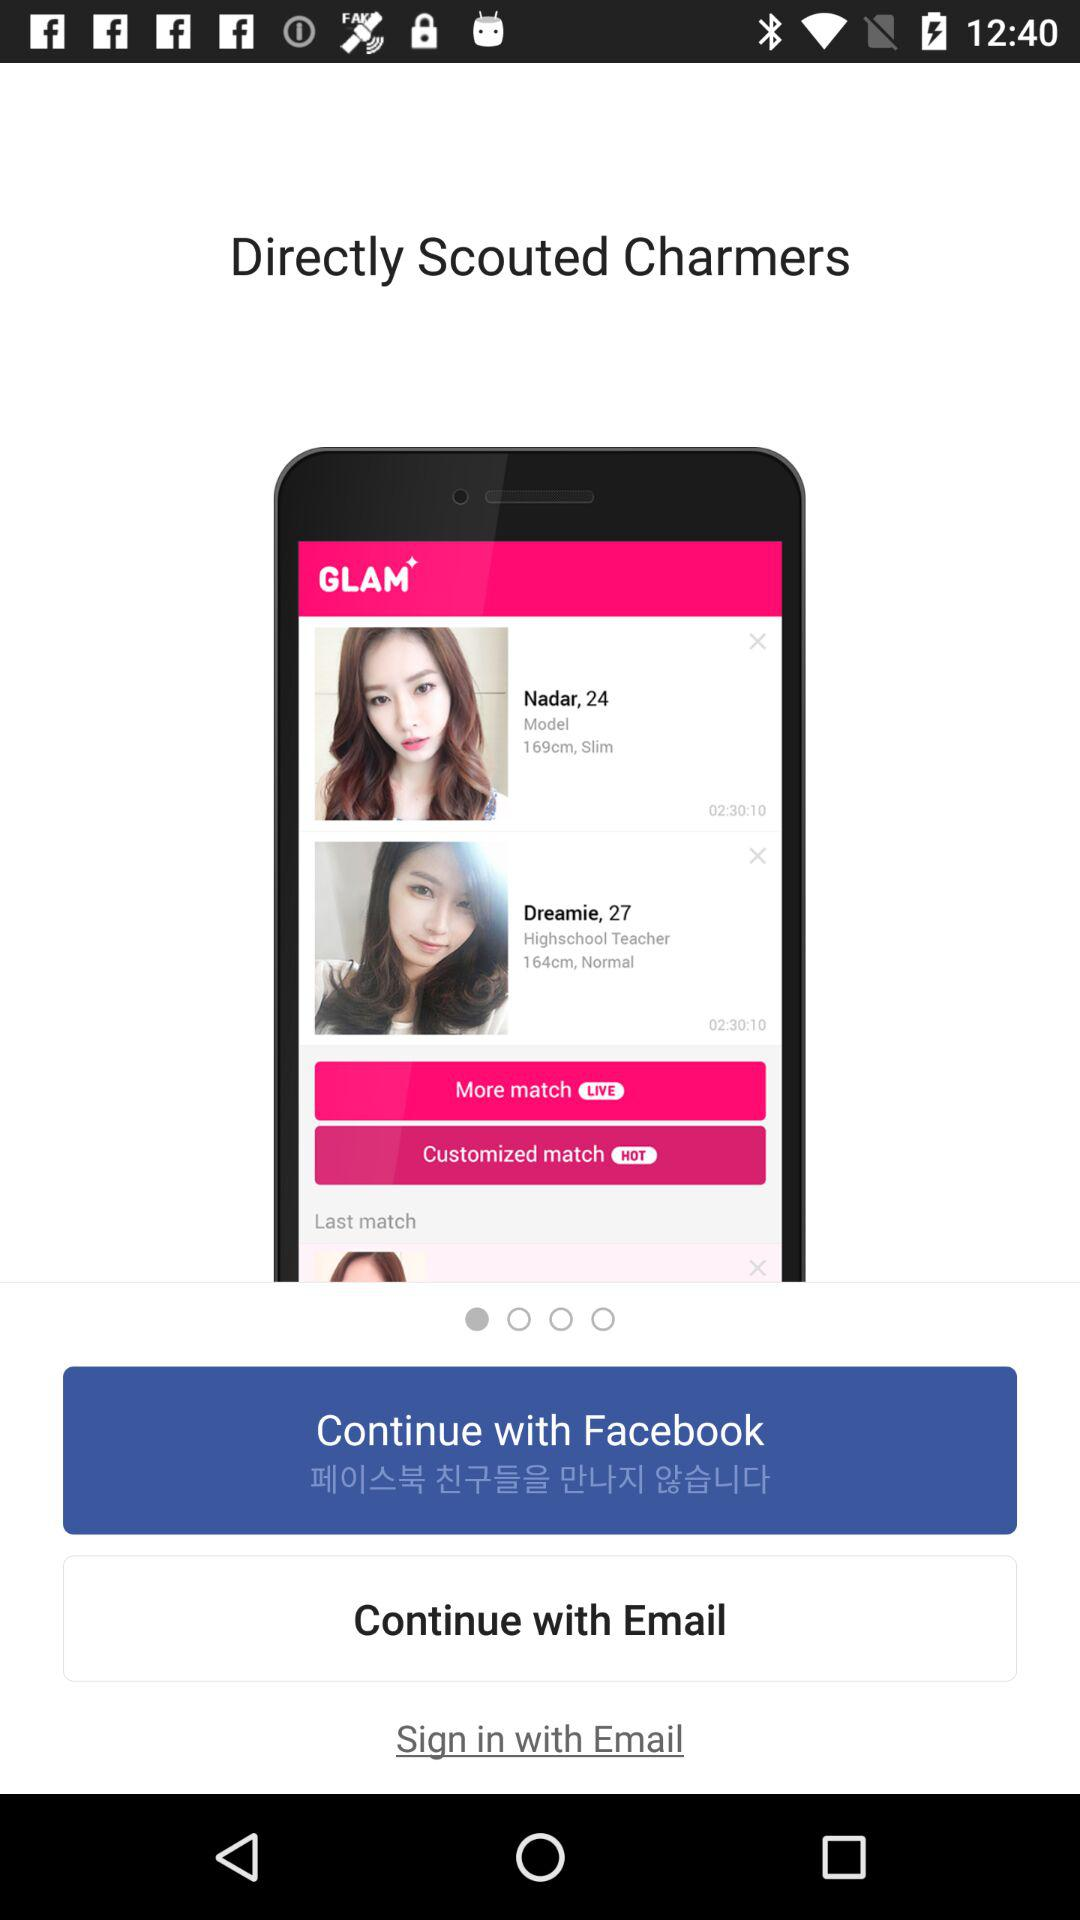What's the height of Dreamie? The height of Dreamie is 164 cm. 